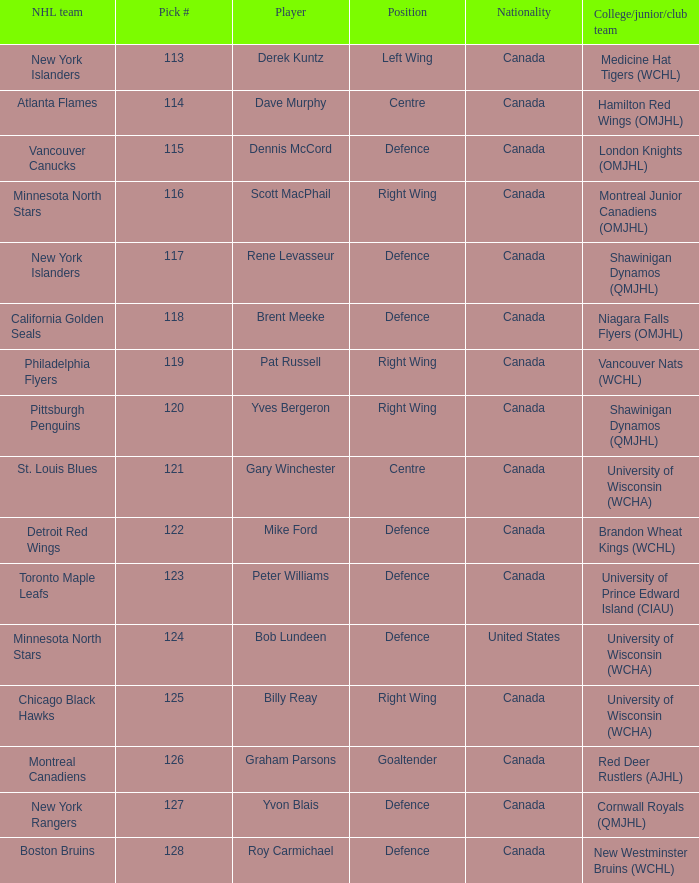Name the college/junior/club team for left wing Medicine Hat Tigers (WCHL). 